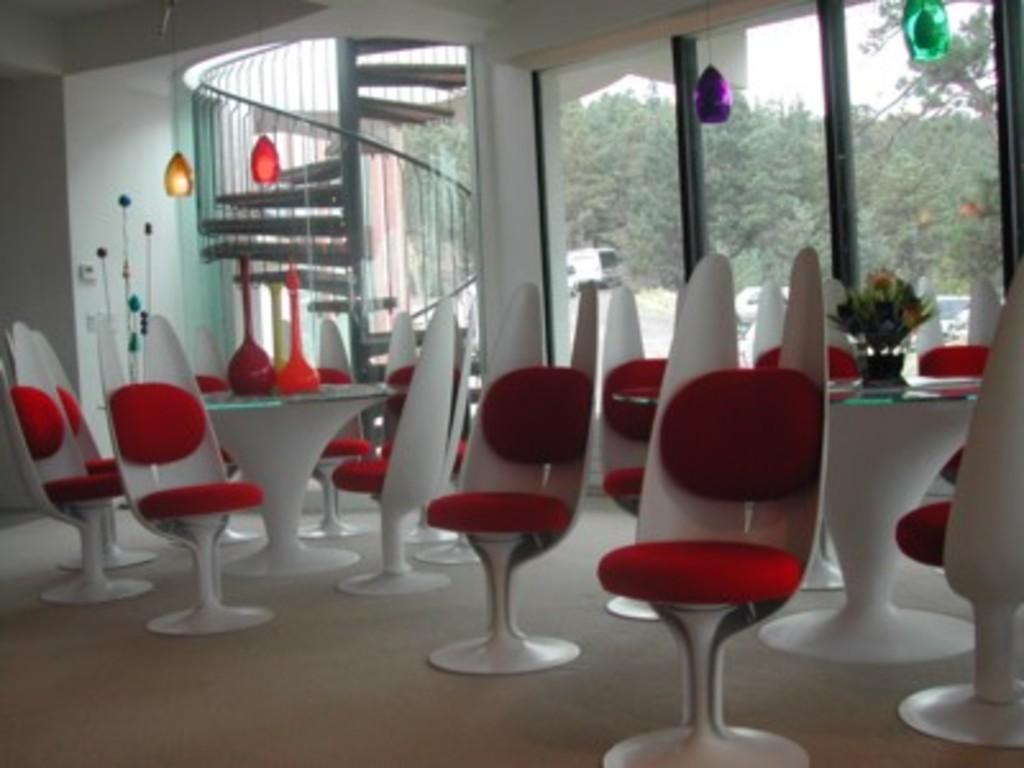What type of furniture can be seen in the image? There are chairs and tables in the image. What architectural feature is present in the image? There is a staircase in the image. What is the background of the image made of? There is a wall in the image. What decorative elements are present in the image? There are decorative objects in the image. What can be seen through the glasses in the image? Trees, a vehicle, and the sky are visible through the glasses. Where is the quiver located in the image? There is no quiver present in the image. How many people are in the crowd in the image? There is no crowd present in the image. 